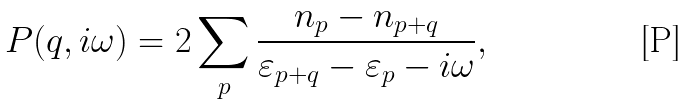<formula> <loc_0><loc_0><loc_500><loc_500>P ( q , i \omega ) = 2 \sum _ { p } \frac { n _ { p } - n _ { p + q } } { \varepsilon _ { p + q } - \varepsilon _ { p } - i \omega } ,</formula> 